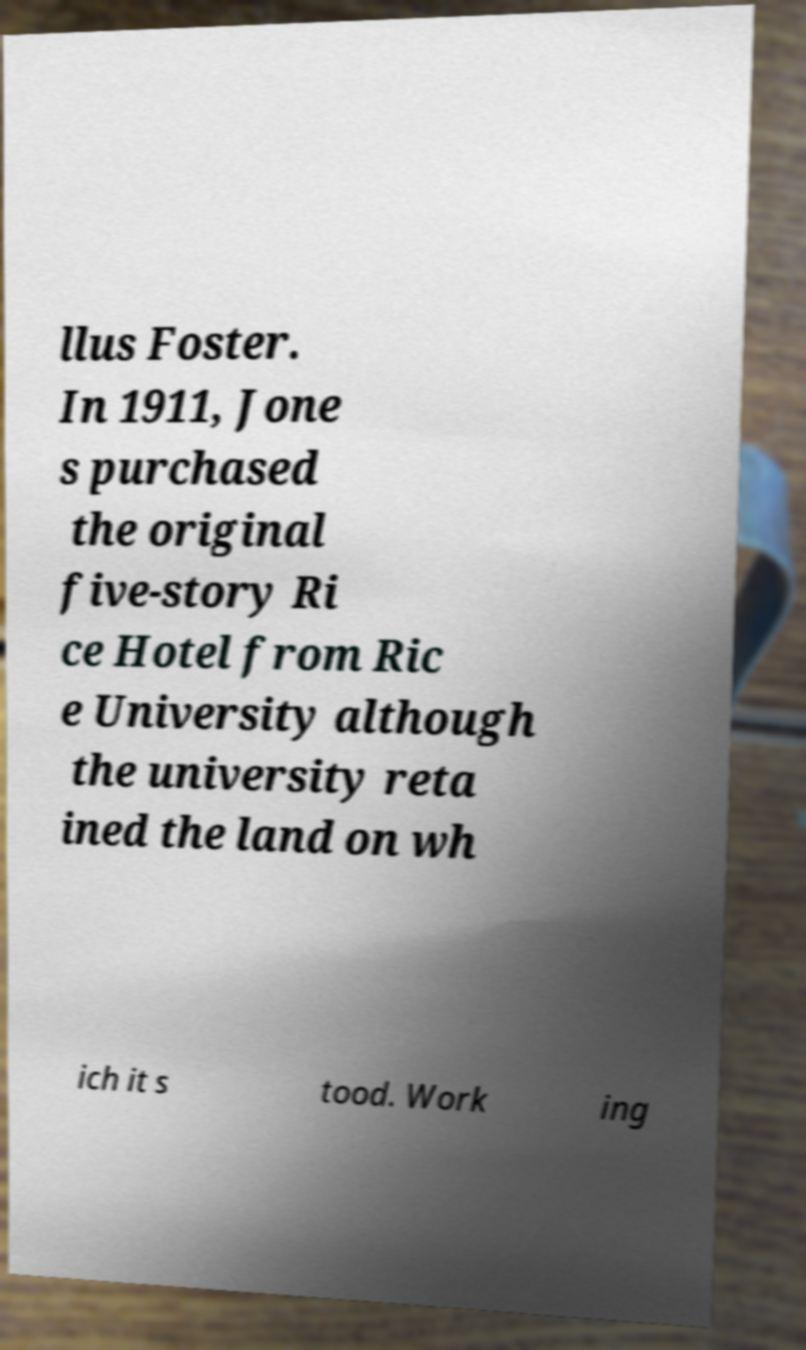Please read and relay the text visible in this image. What does it say? llus Foster. In 1911, Jone s purchased the original five-story Ri ce Hotel from Ric e University although the university reta ined the land on wh ich it s tood. Work ing 